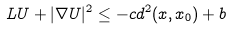<formula> <loc_0><loc_0><loc_500><loc_500>\L L U + | \nabla U | ^ { 2 } \leq - c d ^ { 2 } ( x , x _ { 0 } ) + b</formula> 